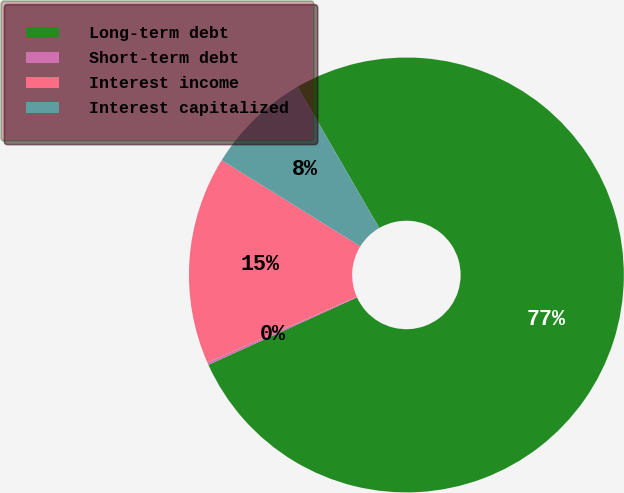<chart> <loc_0><loc_0><loc_500><loc_500><pie_chart><fcel>Long-term debt<fcel>Short-term debt<fcel>Interest income<fcel>Interest capitalized<nl><fcel>76.56%<fcel>0.18%<fcel>15.45%<fcel>7.81%<nl></chart> 